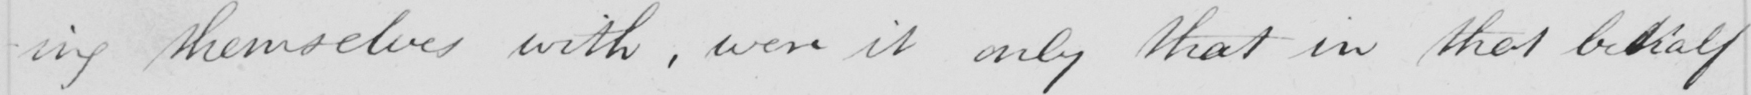What is written in this line of handwriting? -ing themselves with , were it only that in that behalf 